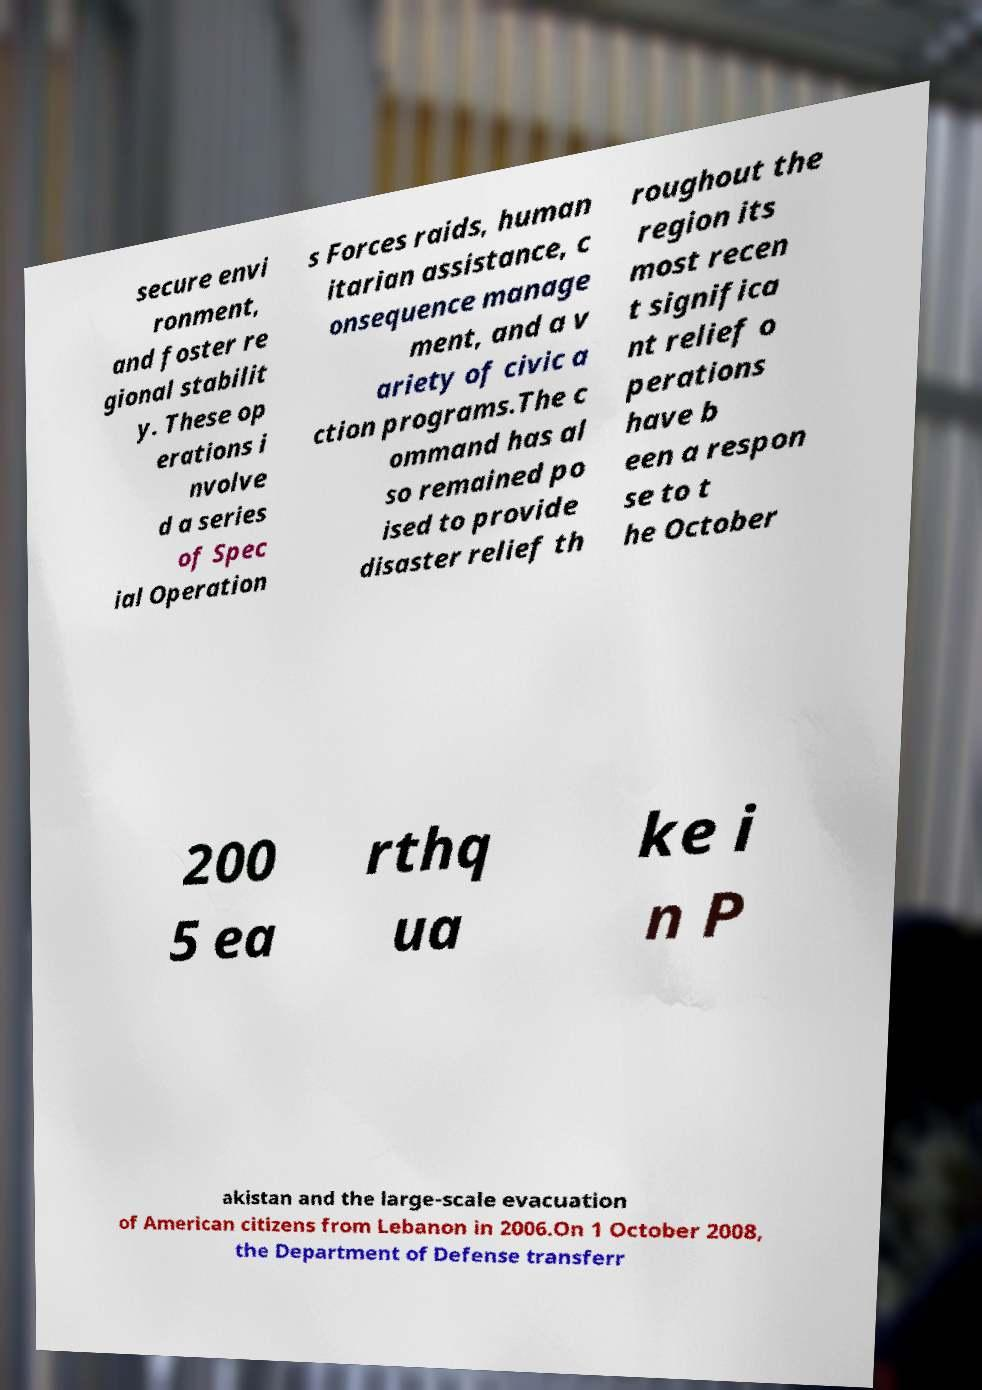I need the written content from this picture converted into text. Can you do that? secure envi ronment, and foster re gional stabilit y. These op erations i nvolve d a series of Spec ial Operation s Forces raids, human itarian assistance, c onsequence manage ment, and a v ariety of civic a ction programs.The c ommand has al so remained po ised to provide disaster relief th roughout the region its most recen t significa nt relief o perations have b een a respon se to t he October 200 5 ea rthq ua ke i n P akistan and the large-scale evacuation of American citizens from Lebanon in 2006.On 1 October 2008, the Department of Defense transferr 